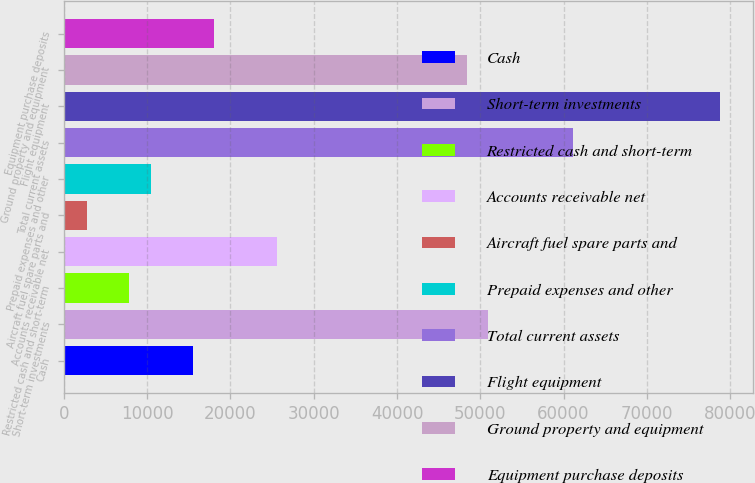<chart> <loc_0><loc_0><loc_500><loc_500><bar_chart><fcel>Cash<fcel>Short-term investments<fcel>Restricted cash and short-term<fcel>Accounts receivable net<fcel>Aircraft fuel spare parts and<fcel>Prepaid expenses and other<fcel>Total current assets<fcel>Flight equipment<fcel>Ground property and equipment<fcel>Equipment purchase deposits<nl><fcel>15478.4<fcel>50946<fcel>7878.2<fcel>25612<fcel>2811.4<fcel>10411.6<fcel>61079.6<fcel>78813.4<fcel>48412.6<fcel>18011.8<nl></chart> 